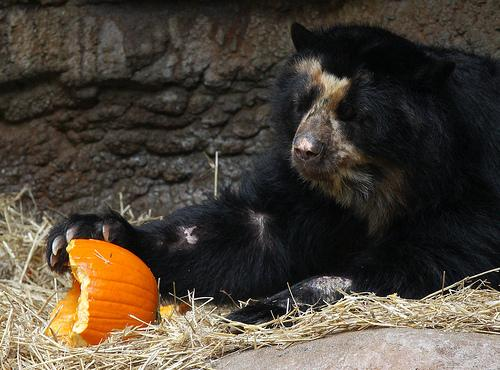Simply outline the primary subject of the image and its activity. Black bear with tan face, grasping a pumpkin, amidst rocky and hay-filled setting. Elaborate on the central character and its surroundings in the image. The image highlights a black bear latching onto an orange pumpkin, revealing its tan face and claws against a rocky and hay-filled backdrop. Mention the primary subject in the image along with its prominent features and any other objects it has contact with. A black bear with a tan face, engaging with an orange pumpkin surrounded by a yellow patch of hay and a rocky background. In one sentence, describe the main animal in the photo and its most distinctive interaction. The image captures a black bear with a tan-colored face, holding onto an orange pumpkin amidst a rocky setting. Provide a brief description of the most prominent object in the image and its actions. A black bear is holding onto an orange pumpkin while showing its tan-colored face and claws. Write a crisp description of the image's focal point and the environment in which it is placed. The photo shows a black bear with a tan face, gripping a pumpkin and situated within a rocky and hay-filled setting. Narrate the primary figure and its action in the image in a simple way. It's a black bear holding a pumpkin, displaying its tan face and claws with a rocky background. What is the most noticeable animal in the picture and what is it interacting with? The most noticeable animal is a black bear holding a pumpkin with some hay and rocky background visible. In a few words, describe the main features of the creature in the picture and its interaction with its surroundings. Black bear holding pumpkin, tan face, bear claws, rocky and hay-filled background featured. Express the key elements and their features in the image in a concise manner. A scene with a black bear grasping a pumpkin, showcasing its tan face, bear claws, and a rocky backdrop. 